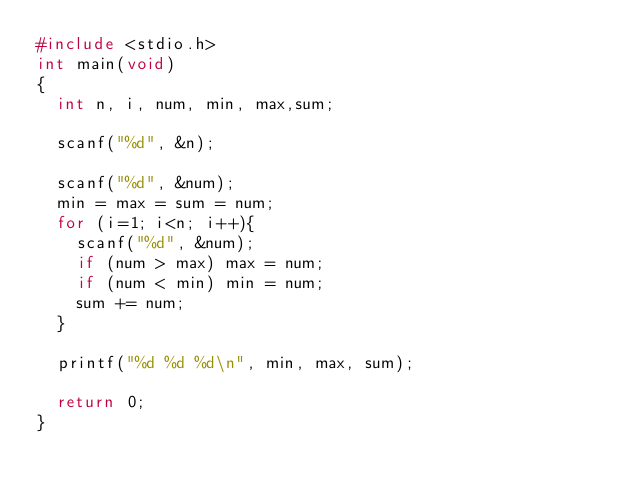<code> <loc_0><loc_0><loc_500><loc_500><_C_>#include <stdio.h>
int main(void)
{
	int n, i, num, min, max,sum;

	scanf("%d", &n);

	scanf("%d", &num);
	min = max = sum = num;
	for (i=1; i<n; i++){
		scanf("%d", &num);
		if (num > max) max = num;
		if (num < min) min = num;
		sum += num;
	}
	
	printf("%d %d %d\n", min, max, sum);

	return 0;
}
</code> 